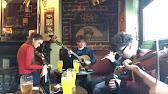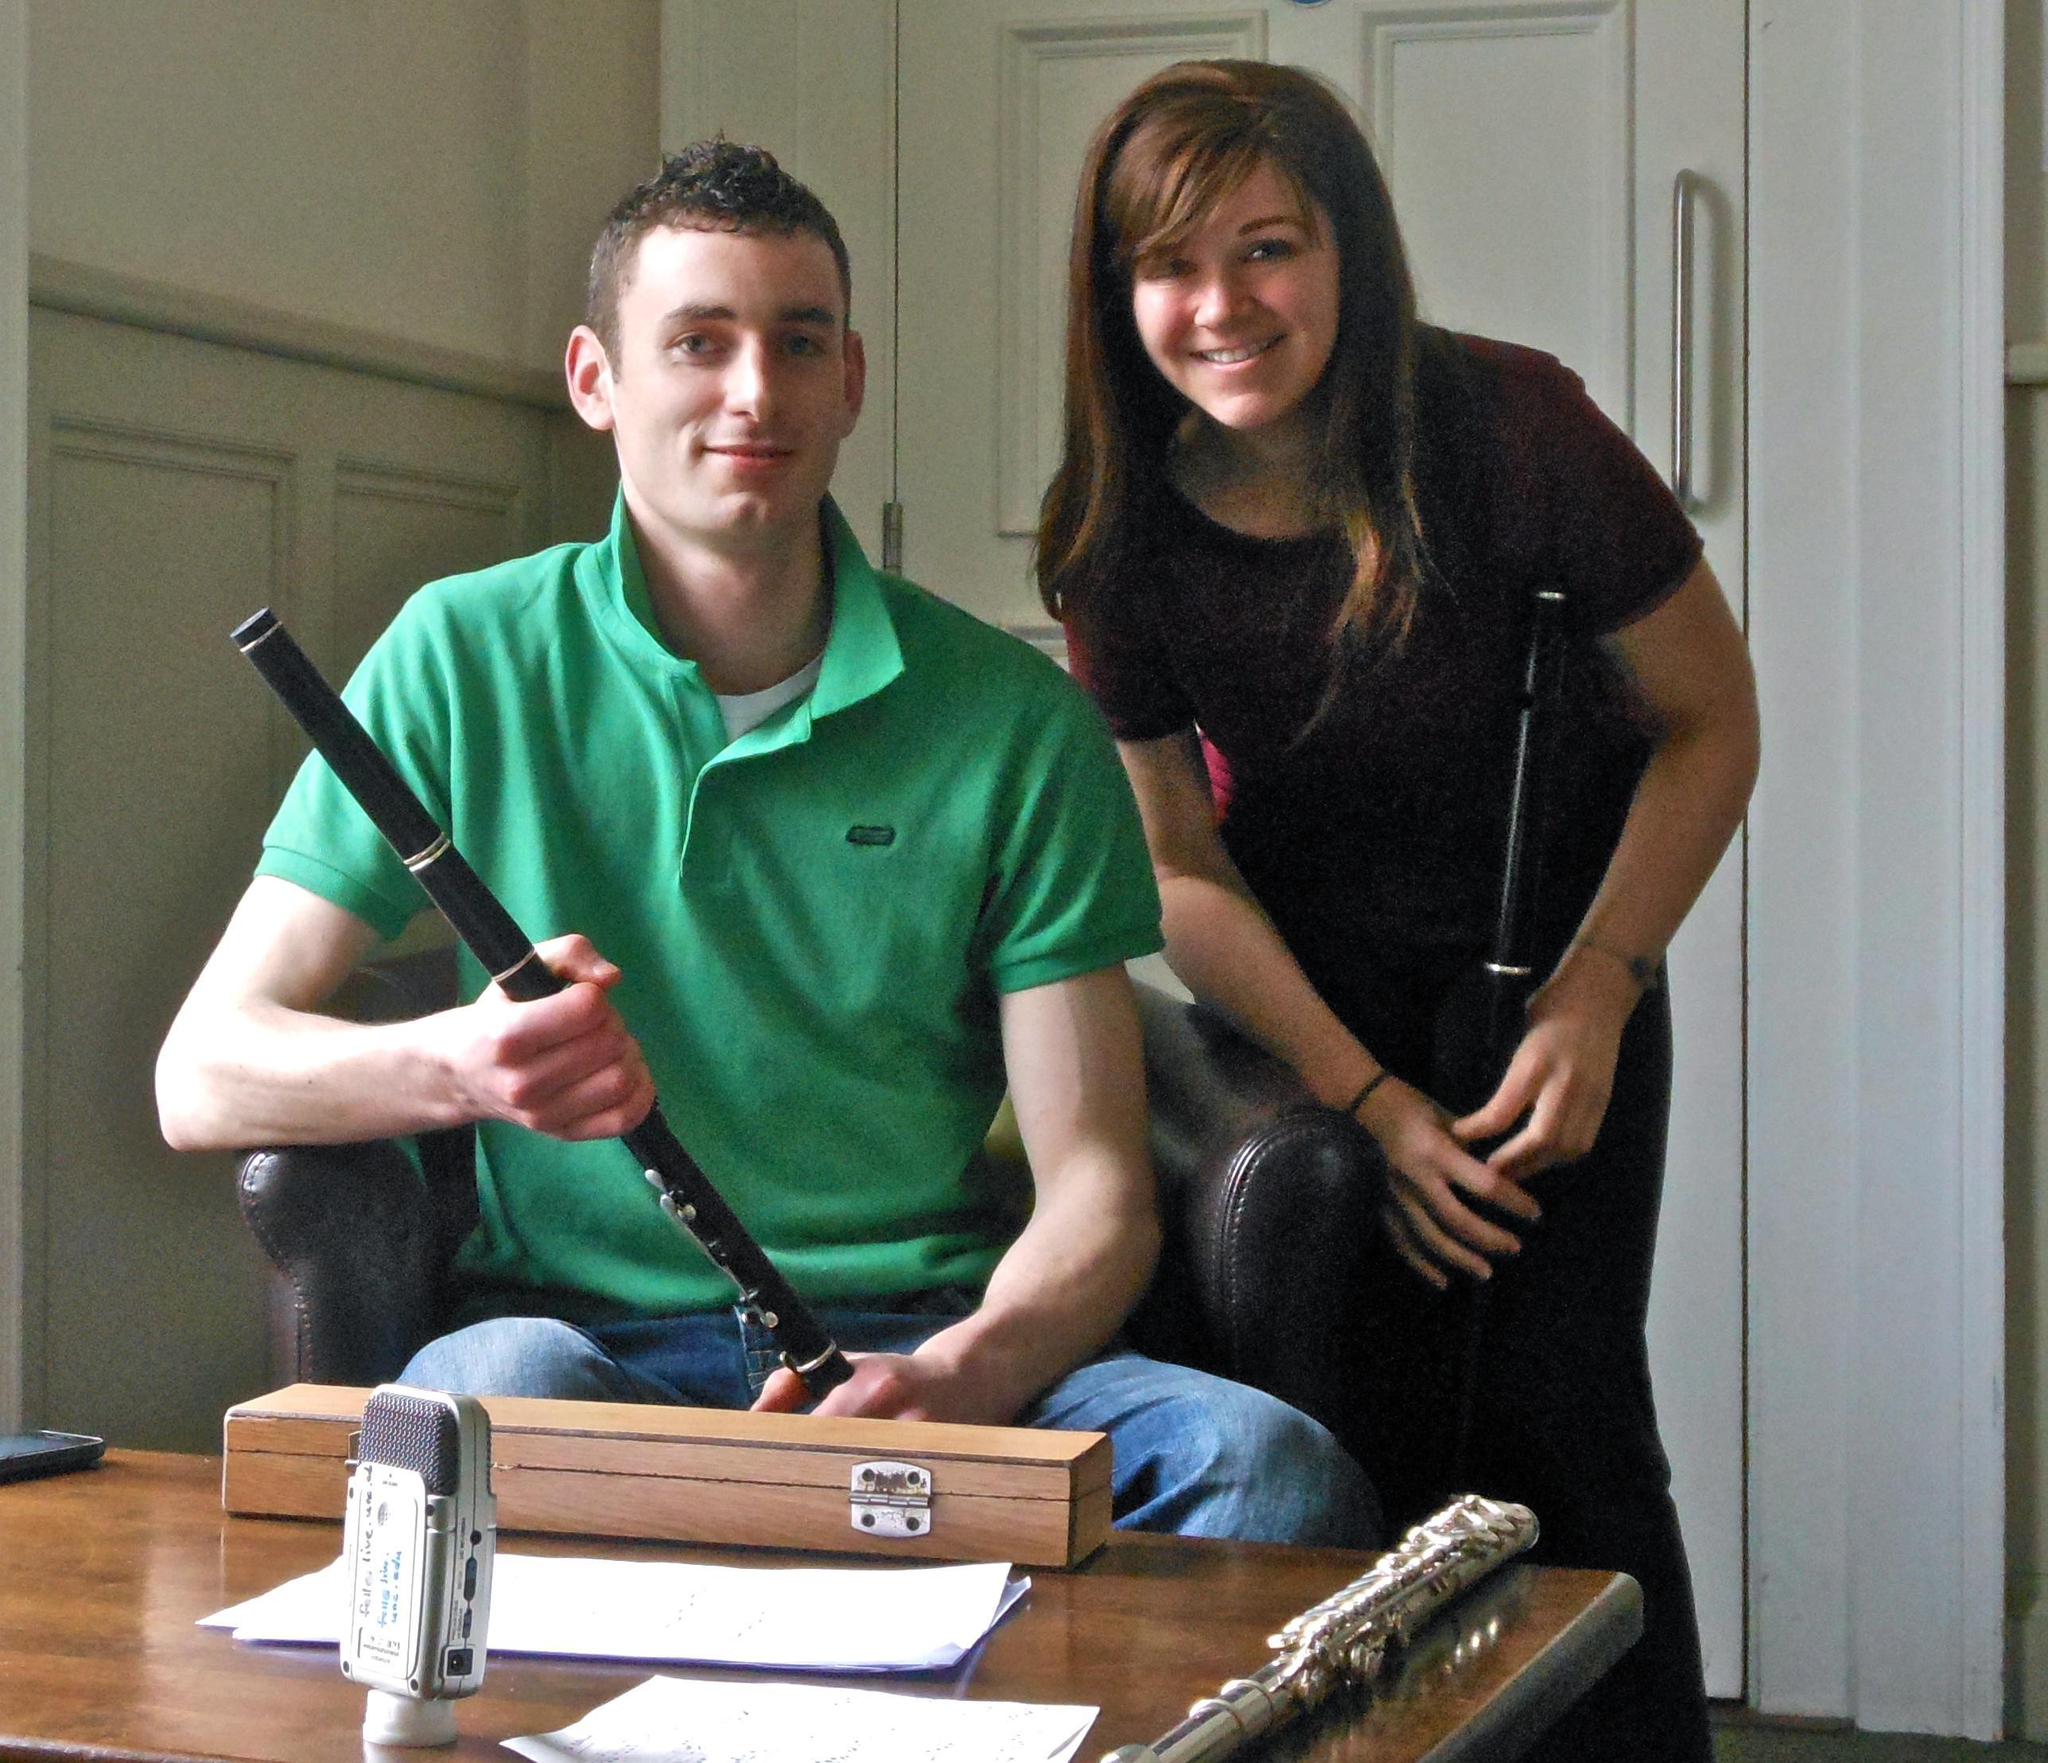The first image is the image on the left, the second image is the image on the right. Evaluate the accuracy of this statement regarding the images: "Two people are playing the flute.". Is it true? Answer yes or no. No. 